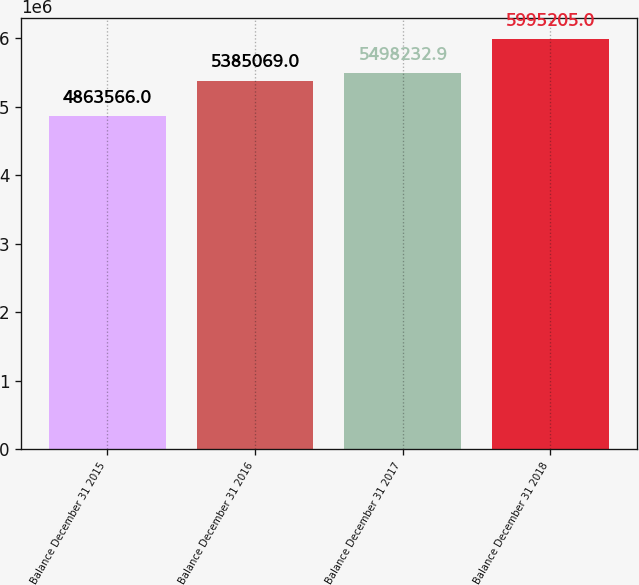Convert chart. <chart><loc_0><loc_0><loc_500><loc_500><bar_chart><fcel>Balance December 31 2015<fcel>Balance December 31 2016<fcel>Balance December 31 2017<fcel>Balance December 31 2018<nl><fcel>4.86357e+06<fcel>5.38507e+06<fcel>5.49823e+06<fcel>5.9952e+06<nl></chart> 